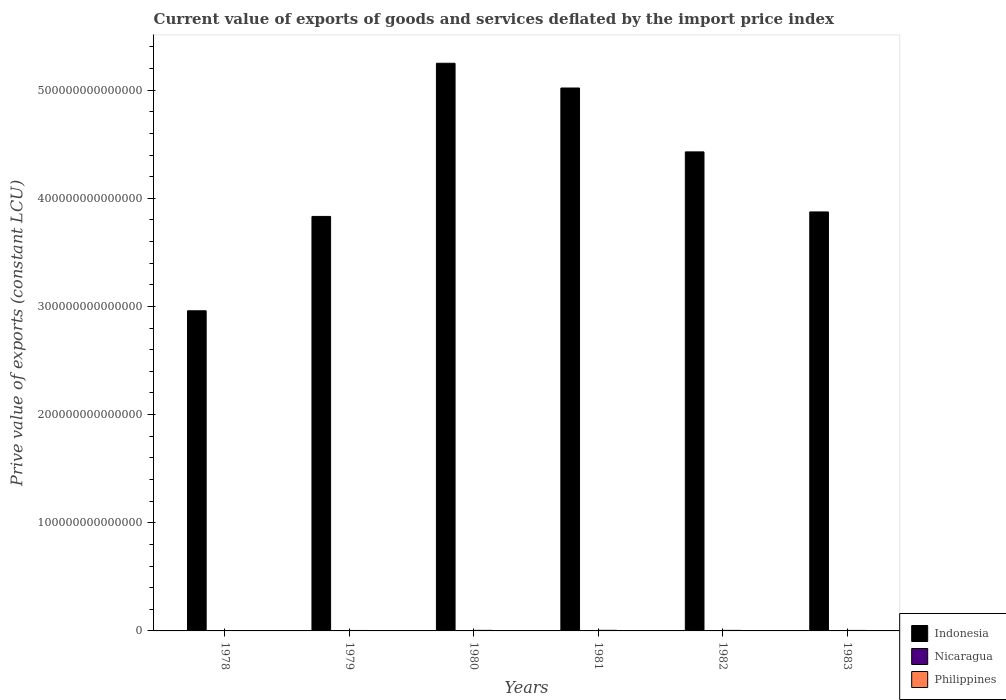How many different coloured bars are there?
Your answer should be compact. 3. How many bars are there on the 3rd tick from the left?
Provide a short and direct response. 3. How many bars are there on the 5th tick from the right?
Provide a succinct answer. 3. What is the label of the 2nd group of bars from the left?
Provide a succinct answer. 1979. In how many cases, is the number of bars for a given year not equal to the number of legend labels?
Make the answer very short. 0. What is the prive value of exports in Philippines in 1980?
Your answer should be compact. 5.16e+11. Across all years, what is the maximum prive value of exports in Philippines?
Your answer should be compact. 5.42e+11. Across all years, what is the minimum prive value of exports in Nicaragua?
Provide a succinct answer. 1.10e+1. In which year was the prive value of exports in Philippines minimum?
Offer a terse response. 1978. What is the total prive value of exports in Indonesia in the graph?
Your answer should be compact. 2.54e+15. What is the difference between the prive value of exports in Philippines in 1978 and that in 1983?
Your response must be concise. -9.46e+1. What is the difference between the prive value of exports in Nicaragua in 1981 and the prive value of exports in Philippines in 1982?
Give a very brief answer. -4.79e+11. What is the average prive value of exports in Indonesia per year?
Ensure brevity in your answer.  4.23e+14. In the year 1981, what is the difference between the prive value of exports in Nicaragua and prive value of exports in Philippines?
Your answer should be very brief. -5.29e+11. In how many years, is the prive value of exports in Indonesia greater than 440000000000000 LCU?
Offer a very short reply. 3. What is the ratio of the prive value of exports in Indonesia in 1978 to that in 1981?
Keep it short and to the point. 0.59. What is the difference between the highest and the second highest prive value of exports in Philippines?
Ensure brevity in your answer.  2.63e+1. What is the difference between the highest and the lowest prive value of exports in Nicaragua?
Provide a succinct answer. 1.02e+1. In how many years, is the prive value of exports in Nicaragua greater than the average prive value of exports in Nicaragua taken over all years?
Make the answer very short. 2. Is the sum of the prive value of exports in Indonesia in 1978 and 1979 greater than the maximum prive value of exports in Nicaragua across all years?
Your answer should be very brief. Yes. What does the 1st bar from the left in 1979 represents?
Keep it short and to the point. Indonesia. What does the 1st bar from the right in 1979 represents?
Your answer should be very brief. Philippines. How many bars are there?
Ensure brevity in your answer.  18. Are all the bars in the graph horizontal?
Make the answer very short. No. What is the difference between two consecutive major ticks on the Y-axis?
Offer a terse response. 1.00e+14. Does the graph contain any zero values?
Give a very brief answer. No. Does the graph contain grids?
Offer a very short reply. No. Where does the legend appear in the graph?
Ensure brevity in your answer.  Bottom right. How many legend labels are there?
Provide a succinct answer. 3. How are the legend labels stacked?
Provide a short and direct response. Vertical. What is the title of the graph?
Your response must be concise. Current value of exports of goods and services deflated by the import price index. What is the label or title of the X-axis?
Offer a very short reply. Years. What is the label or title of the Y-axis?
Give a very brief answer. Prive value of exports (constant LCU). What is the Prive value of exports (constant LCU) in Indonesia in 1978?
Your answer should be compact. 2.96e+14. What is the Prive value of exports (constant LCU) of Nicaragua in 1978?
Offer a very short reply. 1.93e+1. What is the Prive value of exports (constant LCU) in Philippines in 1978?
Provide a short and direct response. 3.72e+11. What is the Prive value of exports (constant LCU) of Indonesia in 1979?
Your answer should be very brief. 3.83e+14. What is the Prive value of exports (constant LCU) in Nicaragua in 1979?
Give a very brief answer. 2.13e+1. What is the Prive value of exports (constant LCU) in Philippines in 1979?
Keep it short and to the point. 4.22e+11. What is the Prive value of exports (constant LCU) of Indonesia in 1980?
Your answer should be very brief. 5.25e+14. What is the Prive value of exports (constant LCU) in Nicaragua in 1980?
Your response must be concise. 1.45e+1. What is the Prive value of exports (constant LCU) in Philippines in 1980?
Offer a terse response. 5.16e+11. What is the Prive value of exports (constant LCU) in Indonesia in 1981?
Provide a short and direct response. 5.02e+14. What is the Prive value of exports (constant LCU) of Nicaragua in 1981?
Provide a succinct answer. 1.32e+1. What is the Prive value of exports (constant LCU) in Philippines in 1981?
Make the answer very short. 5.42e+11. What is the Prive value of exports (constant LCU) in Indonesia in 1982?
Your answer should be compact. 4.43e+14. What is the Prive value of exports (constant LCU) of Nicaragua in 1982?
Offer a terse response. 1.10e+1. What is the Prive value of exports (constant LCU) of Philippines in 1982?
Provide a short and direct response. 4.93e+11. What is the Prive value of exports (constant LCU) in Indonesia in 1983?
Give a very brief answer. 3.87e+14. What is the Prive value of exports (constant LCU) in Nicaragua in 1983?
Offer a very short reply. 1.36e+1. What is the Prive value of exports (constant LCU) of Philippines in 1983?
Make the answer very short. 4.66e+11. Across all years, what is the maximum Prive value of exports (constant LCU) in Indonesia?
Your response must be concise. 5.25e+14. Across all years, what is the maximum Prive value of exports (constant LCU) in Nicaragua?
Ensure brevity in your answer.  2.13e+1. Across all years, what is the maximum Prive value of exports (constant LCU) of Philippines?
Your answer should be very brief. 5.42e+11. Across all years, what is the minimum Prive value of exports (constant LCU) in Indonesia?
Provide a short and direct response. 2.96e+14. Across all years, what is the minimum Prive value of exports (constant LCU) in Nicaragua?
Provide a short and direct response. 1.10e+1. Across all years, what is the minimum Prive value of exports (constant LCU) of Philippines?
Ensure brevity in your answer.  3.72e+11. What is the total Prive value of exports (constant LCU) of Indonesia in the graph?
Provide a succinct answer. 2.54e+15. What is the total Prive value of exports (constant LCU) in Nicaragua in the graph?
Ensure brevity in your answer.  9.29e+1. What is the total Prive value of exports (constant LCU) in Philippines in the graph?
Make the answer very short. 2.81e+12. What is the difference between the Prive value of exports (constant LCU) in Indonesia in 1978 and that in 1979?
Make the answer very short. -8.72e+13. What is the difference between the Prive value of exports (constant LCU) in Nicaragua in 1978 and that in 1979?
Keep it short and to the point. -1.97e+09. What is the difference between the Prive value of exports (constant LCU) in Philippines in 1978 and that in 1979?
Provide a succinct answer. -4.98e+1. What is the difference between the Prive value of exports (constant LCU) of Indonesia in 1978 and that in 1980?
Ensure brevity in your answer.  -2.29e+14. What is the difference between the Prive value of exports (constant LCU) of Nicaragua in 1978 and that in 1980?
Provide a short and direct response. 4.82e+09. What is the difference between the Prive value of exports (constant LCU) of Philippines in 1978 and that in 1980?
Your answer should be compact. -1.44e+11. What is the difference between the Prive value of exports (constant LCU) of Indonesia in 1978 and that in 1981?
Keep it short and to the point. -2.06e+14. What is the difference between the Prive value of exports (constant LCU) in Nicaragua in 1978 and that in 1981?
Offer a terse response. 6.08e+09. What is the difference between the Prive value of exports (constant LCU) of Philippines in 1978 and that in 1981?
Your response must be concise. -1.70e+11. What is the difference between the Prive value of exports (constant LCU) in Indonesia in 1978 and that in 1982?
Offer a terse response. -1.47e+14. What is the difference between the Prive value of exports (constant LCU) in Nicaragua in 1978 and that in 1982?
Ensure brevity in your answer.  8.25e+09. What is the difference between the Prive value of exports (constant LCU) in Philippines in 1978 and that in 1982?
Offer a very short reply. -1.21e+11. What is the difference between the Prive value of exports (constant LCU) in Indonesia in 1978 and that in 1983?
Keep it short and to the point. -9.14e+13. What is the difference between the Prive value of exports (constant LCU) of Nicaragua in 1978 and that in 1983?
Give a very brief answer. 5.69e+09. What is the difference between the Prive value of exports (constant LCU) in Philippines in 1978 and that in 1983?
Offer a very short reply. -9.46e+1. What is the difference between the Prive value of exports (constant LCU) of Indonesia in 1979 and that in 1980?
Provide a succinct answer. -1.42e+14. What is the difference between the Prive value of exports (constant LCU) of Nicaragua in 1979 and that in 1980?
Your answer should be compact. 6.79e+09. What is the difference between the Prive value of exports (constant LCU) in Philippines in 1979 and that in 1980?
Your answer should be compact. -9.42e+1. What is the difference between the Prive value of exports (constant LCU) of Indonesia in 1979 and that in 1981?
Your answer should be compact. -1.19e+14. What is the difference between the Prive value of exports (constant LCU) of Nicaragua in 1979 and that in 1981?
Give a very brief answer. 8.05e+09. What is the difference between the Prive value of exports (constant LCU) of Philippines in 1979 and that in 1981?
Give a very brief answer. -1.20e+11. What is the difference between the Prive value of exports (constant LCU) of Indonesia in 1979 and that in 1982?
Provide a succinct answer. -5.97e+13. What is the difference between the Prive value of exports (constant LCU) in Nicaragua in 1979 and that in 1982?
Your answer should be compact. 1.02e+1. What is the difference between the Prive value of exports (constant LCU) of Philippines in 1979 and that in 1982?
Keep it short and to the point. -7.10e+1. What is the difference between the Prive value of exports (constant LCU) in Indonesia in 1979 and that in 1983?
Ensure brevity in your answer.  -4.15e+12. What is the difference between the Prive value of exports (constant LCU) in Nicaragua in 1979 and that in 1983?
Make the answer very short. 7.66e+09. What is the difference between the Prive value of exports (constant LCU) of Philippines in 1979 and that in 1983?
Your answer should be compact. -4.48e+1. What is the difference between the Prive value of exports (constant LCU) in Indonesia in 1980 and that in 1981?
Your answer should be very brief. 2.29e+13. What is the difference between the Prive value of exports (constant LCU) of Nicaragua in 1980 and that in 1981?
Give a very brief answer. 1.26e+09. What is the difference between the Prive value of exports (constant LCU) of Philippines in 1980 and that in 1981?
Your answer should be very brief. -2.63e+1. What is the difference between the Prive value of exports (constant LCU) of Indonesia in 1980 and that in 1982?
Your answer should be compact. 8.20e+13. What is the difference between the Prive value of exports (constant LCU) in Nicaragua in 1980 and that in 1982?
Make the answer very short. 3.43e+09. What is the difference between the Prive value of exports (constant LCU) in Philippines in 1980 and that in 1982?
Your answer should be very brief. 2.32e+1. What is the difference between the Prive value of exports (constant LCU) in Indonesia in 1980 and that in 1983?
Give a very brief answer. 1.37e+14. What is the difference between the Prive value of exports (constant LCU) in Nicaragua in 1980 and that in 1983?
Keep it short and to the point. 8.69e+08. What is the difference between the Prive value of exports (constant LCU) in Philippines in 1980 and that in 1983?
Offer a very short reply. 4.93e+1. What is the difference between the Prive value of exports (constant LCU) of Indonesia in 1981 and that in 1982?
Your answer should be very brief. 5.91e+13. What is the difference between the Prive value of exports (constant LCU) of Nicaragua in 1981 and that in 1982?
Give a very brief answer. 2.17e+09. What is the difference between the Prive value of exports (constant LCU) in Philippines in 1981 and that in 1982?
Offer a terse response. 4.95e+1. What is the difference between the Prive value of exports (constant LCU) of Indonesia in 1981 and that in 1983?
Provide a succinct answer. 1.15e+14. What is the difference between the Prive value of exports (constant LCU) of Nicaragua in 1981 and that in 1983?
Provide a succinct answer. -3.90e+08. What is the difference between the Prive value of exports (constant LCU) of Philippines in 1981 and that in 1983?
Your response must be concise. 7.56e+1. What is the difference between the Prive value of exports (constant LCU) in Indonesia in 1982 and that in 1983?
Your answer should be compact. 5.55e+13. What is the difference between the Prive value of exports (constant LCU) in Nicaragua in 1982 and that in 1983?
Give a very brief answer. -2.56e+09. What is the difference between the Prive value of exports (constant LCU) in Philippines in 1982 and that in 1983?
Give a very brief answer. 2.62e+1. What is the difference between the Prive value of exports (constant LCU) in Indonesia in 1978 and the Prive value of exports (constant LCU) in Nicaragua in 1979?
Ensure brevity in your answer.  2.96e+14. What is the difference between the Prive value of exports (constant LCU) of Indonesia in 1978 and the Prive value of exports (constant LCU) of Philippines in 1979?
Your response must be concise. 2.96e+14. What is the difference between the Prive value of exports (constant LCU) in Nicaragua in 1978 and the Prive value of exports (constant LCU) in Philippines in 1979?
Provide a succinct answer. -4.02e+11. What is the difference between the Prive value of exports (constant LCU) of Indonesia in 1978 and the Prive value of exports (constant LCU) of Nicaragua in 1980?
Your answer should be compact. 2.96e+14. What is the difference between the Prive value of exports (constant LCU) of Indonesia in 1978 and the Prive value of exports (constant LCU) of Philippines in 1980?
Provide a short and direct response. 2.95e+14. What is the difference between the Prive value of exports (constant LCU) in Nicaragua in 1978 and the Prive value of exports (constant LCU) in Philippines in 1980?
Provide a succinct answer. -4.96e+11. What is the difference between the Prive value of exports (constant LCU) in Indonesia in 1978 and the Prive value of exports (constant LCU) in Nicaragua in 1981?
Your response must be concise. 2.96e+14. What is the difference between the Prive value of exports (constant LCU) of Indonesia in 1978 and the Prive value of exports (constant LCU) of Philippines in 1981?
Ensure brevity in your answer.  2.95e+14. What is the difference between the Prive value of exports (constant LCU) in Nicaragua in 1978 and the Prive value of exports (constant LCU) in Philippines in 1981?
Offer a terse response. -5.23e+11. What is the difference between the Prive value of exports (constant LCU) of Indonesia in 1978 and the Prive value of exports (constant LCU) of Nicaragua in 1982?
Your response must be concise. 2.96e+14. What is the difference between the Prive value of exports (constant LCU) in Indonesia in 1978 and the Prive value of exports (constant LCU) in Philippines in 1982?
Keep it short and to the point. 2.96e+14. What is the difference between the Prive value of exports (constant LCU) in Nicaragua in 1978 and the Prive value of exports (constant LCU) in Philippines in 1982?
Your answer should be compact. -4.73e+11. What is the difference between the Prive value of exports (constant LCU) in Indonesia in 1978 and the Prive value of exports (constant LCU) in Nicaragua in 1983?
Keep it short and to the point. 2.96e+14. What is the difference between the Prive value of exports (constant LCU) of Indonesia in 1978 and the Prive value of exports (constant LCU) of Philippines in 1983?
Make the answer very short. 2.96e+14. What is the difference between the Prive value of exports (constant LCU) of Nicaragua in 1978 and the Prive value of exports (constant LCU) of Philippines in 1983?
Ensure brevity in your answer.  -4.47e+11. What is the difference between the Prive value of exports (constant LCU) of Indonesia in 1979 and the Prive value of exports (constant LCU) of Nicaragua in 1980?
Your response must be concise. 3.83e+14. What is the difference between the Prive value of exports (constant LCU) in Indonesia in 1979 and the Prive value of exports (constant LCU) in Philippines in 1980?
Your answer should be very brief. 3.83e+14. What is the difference between the Prive value of exports (constant LCU) of Nicaragua in 1979 and the Prive value of exports (constant LCU) of Philippines in 1980?
Offer a terse response. -4.94e+11. What is the difference between the Prive value of exports (constant LCU) of Indonesia in 1979 and the Prive value of exports (constant LCU) of Nicaragua in 1981?
Give a very brief answer. 3.83e+14. What is the difference between the Prive value of exports (constant LCU) in Indonesia in 1979 and the Prive value of exports (constant LCU) in Philippines in 1981?
Ensure brevity in your answer.  3.83e+14. What is the difference between the Prive value of exports (constant LCU) in Nicaragua in 1979 and the Prive value of exports (constant LCU) in Philippines in 1981?
Your response must be concise. -5.21e+11. What is the difference between the Prive value of exports (constant LCU) of Indonesia in 1979 and the Prive value of exports (constant LCU) of Nicaragua in 1982?
Make the answer very short. 3.83e+14. What is the difference between the Prive value of exports (constant LCU) of Indonesia in 1979 and the Prive value of exports (constant LCU) of Philippines in 1982?
Your answer should be compact. 3.83e+14. What is the difference between the Prive value of exports (constant LCU) in Nicaragua in 1979 and the Prive value of exports (constant LCU) in Philippines in 1982?
Offer a very short reply. -4.71e+11. What is the difference between the Prive value of exports (constant LCU) of Indonesia in 1979 and the Prive value of exports (constant LCU) of Nicaragua in 1983?
Offer a very short reply. 3.83e+14. What is the difference between the Prive value of exports (constant LCU) of Indonesia in 1979 and the Prive value of exports (constant LCU) of Philippines in 1983?
Your answer should be compact. 3.83e+14. What is the difference between the Prive value of exports (constant LCU) of Nicaragua in 1979 and the Prive value of exports (constant LCU) of Philippines in 1983?
Keep it short and to the point. -4.45e+11. What is the difference between the Prive value of exports (constant LCU) of Indonesia in 1980 and the Prive value of exports (constant LCU) of Nicaragua in 1981?
Your answer should be compact. 5.25e+14. What is the difference between the Prive value of exports (constant LCU) in Indonesia in 1980 and the Prive value of exports (constant LCU) in Philippines in 1981?
Ensure brevity in your answer.  5.24e+14. What is the difference between the Prive value of exports (constant LCU) in Nicaragua in 1980 and the Prive value of exports (constant LCU) in Philippines in 1981?
Provide a succinct answer. -5.28e+11. What is the difference between the Prive value of exports (constant LCU) in Indonesia in 1980 and the Prive value of exports (constant LCU) in Nicaragua in 1982?
Offer a terse response. 5.25e+14. What is the difference between the Prive value of exports (constant LCU) of Indonesia in 1980 and the Prive value of exports (constant LCU) of Philippines in 1982?
Ensure brevity in your answer.  5.24e+14. What is the difference between the Prive value of exports (constant LCU) of Nicaragua in 1980 and the Prive value of exports (constant LCU) of Philippines in 1982?
Offer a very short reply. -4.78e+11. What is the difference between the Prive value of exports (constant LCU) in Indonesia in 1980 and the Prive value of exports (constant LCU) in Nicaragua in 1983?
Make the answer very short. 5.25e+14. What is the difference between the Prive value of exports (constant LCU) in Indonesia in 1980 and the Prive value of exports (constant LCU) in Philippines in 1983?
Offer a terse response. 5.24e+14. What is the difference between the Prive value of exports (constant LCU) of Nicaragua in 1980 and the Prive value of exports (constant LCU) of Philippines in 1983?
Make the answer very short. -4.52e+11. What is the difference between the Prive value of exports (constant LCU) in Indonesia in 1981 and the Prive value of exports (constant LCU) in Nicaragua in 1982?
Offer a terse response. 5.02e+14. What is the difference between the Prive value of exports (constant LCU) in Indonesia in 1981 and the Prive value of exports (constant LCU) in Philippines in 1982?
Make the answer very short. 5.01e+14. What is the difference between the Prive value of exports (constant LCU) of Nicaragua in 1981 and the Prive value of exports (constant LCU) of Philippines in 1982?
Give a very brief answer. -4.79e+11. What is the difference between the Prive value of exports (constant LCU) of Indonesia in 1981 and the Prive value of exports (constant LCU) of Nicaragua in 1983?
Keep it short and to the point. 5.02e+14. What is the difference between the Prive value of exports (constant LCU) in Indonesia in 1981 and the Prive value of exports (constant LCU) in Philippines in 1983?
Make the answer very short. 5.02e+14. What is the difference between the Prive value of exports (constant LCU) in Nicaragua in 1981 and the Prive value of exports (constant LCU) in Philippines in 1983?
Offer a very short reply. -4.53e+11. What is the difference between the Prive value of exports (constant LCU) of Indonesia in 1982 and the Prive value of exports (constant LCU) of Nicaragua in 1983?
Keep it short and to the point. 4.43e+14. What is the difference between the Prive value of exports (constant LCU) of Indonesia in 1982 and the Prive value of exports (constant LCU) of Philippines in 1983?
Ensure brevity in your answer.  4.42e+14. What is the difference between the Prive value of exports (constant LCU) of Nicaragua in 1982 and the Prive value of exports (constant LCU) of Philippines in 1983?
Your response must be concise. -4.55e+11. What is the average Prive value of exports (constant LCU) in Indonesia per year?
Your answer should be very brief. 4.23e+14. What is the average Prive value of exports (constant LCU) in Nicaragua per year?
Offer a very short reply. 1.55e+1. What is the average Prive value of exports (constant LCU) of Philippines per year?
Your answer should be compact. 4.68e+11. In the year 1978, what is the difference between the Prive value of exports (constant LCU) of Indonesia and Prive value of exports (constant LCU) of Nicaragua?
Provide a short and direct response. 2.96e+14. In the year 1978, what is the difference between the Prive value of exports (constant LCU) in Indonesia and Prive value of exports (constant LCU) in Philippines?
Make the answer very short. 2.96e+14. In the year 1978, what is the difference between the Prive value of exports (constant LCU) of Nicaragua and Prive value of exports (constant LCU) of Philippines?
Give a very brief answer. -3.52e+11. In the year 1979, what is the difference between the Prive value of exports (constant LCU) in Indonesia and Prive value of exports (constant LCU) in Nicaragua?
Your response must be concise. 3.83e+14. In the year 1979, what is the difference between the Prive value of exports (constant LCU) in Indonesia and Prive value of exports (constant LCU) in Philippines?
Provide a succinct answer. 3.83e+14. In the year 1979, what is the difference between the Prive value of exports (constant LCU) of Nicaragua and Prive value of exports (constant LCU) of Philippines?
Your response must be concise. -4.00e+11. In the year 1980, what is the difference between the Prive value of exports (constant LCU) of Indonesia and Prive value of exports (constant LCU) of Nicaragua?
Give a very brief answer. 5.25e+14. In the year 1980, what is the difference between the Prive value of exports (constant LCU) in Indonesia and Prive value of exports (constant LCU) in Philippines?
Provide a short and direct response. 5.24e+14. In the year 1980, what is the difference between the Prive value of exports (constant LCU) of Nicaragua and Prive value of exports (constant LCU) of Philippines?
Your response must be concise. -5.01e+11. In the year 1981, what is the difference between the Prive value of exports (constant LCU) of Indonesia and Prive value of exports (constant LCU) of Nicaragua?
Your answer should be very brief. 5.02e+14. In the year 1981, what is the difference between the Prive value of exports (constant LCU) in Indonesia and Prive value of exports (constant LCU) in Philippines?
Your answer should be compact. 5.01e+14. In the year 1981, what is the difference between the Prive value of exports (constant LCU) in Nicaragua and Prive value of exports (constant LCU) in Philippines?
Provide a short and direct response. -5.29e+11. In the year 1982, what is the difference between the Prive value of exports (constant LCU) in Indonesia and Prive value of exports (constant LCU) in Nicaragua?
Keep it short and to the point. 4.43e+14. In the year 1982, what is the difference between the Prive value of exports (constant LCU) of Indonesia and Prive value of exports (constant LCU) of Philippines?
Your answer should be very brief. 4.42e+14. In the year 1982, what is the difference between the Prive value of exports (constant LCU) in Nicaragua and Prive value of exports (constant LCU) in Philippines?
Offer a very short reply. -4.82e+11. In the year 1983, what is the difference between the Prive value of exports (constant LCU) in Indonesia and Prive value of exports (constant LCU) in Nicaragua?
Keep it short and to the point. 3.87e+14. In the year 1983, what is the difference between the Prive value of exports (constant LCU) of Indonesia and Prive value of exports (constant LCU) of Philippines?
Your response must be concise. 3.87e+14. In the year 1983, what is the difference between the Prive value of exports (constant LCU) of Nicaragua and Prive value of exports (constant LCU) of Philippines?
Your answer should be compact. -4.53e+11. What is the ratio of the Prive value of exports (constant LCU) of Indonesia in 1978 to that in 1979?
Provide a short and direct response. 0.77. What is the ratio of the Prive value of exports (constant LCU) of Nicaragua in 1978 to that in 1979?
Offer a terse response. 0.91. What is the ratio of the Prive value of exports (constant LCU) in Philippines in 1978 to that in 1979?
Make the answer very short. 0.88. What is the ratio of the Prive value of exports (constant LCU) in Indonesia in 1978 to that in 1980?
Provide a short and direct response. 0.56. What is the ratio of the Prive value of exports (constant LCU) in Nicaragua in 1978 to that in 1980?
Ensure brevity in your answer.  1.33. What is the ratio of the Prive value of exports (constant LCU) in Philippines in 1978 to that in 1980?
Your answer should be very brief. 0.72. What is the ratio of the Prive value of exports (constant LCU) of Indonesia in 1978 to that in 1981?
Your answer should be compact. 0.59. What is the ratio of the Prive value of exports (constant LCU) in Nicaragua in 1978 to that in 1981?
Make the answer very short. 1.46. What is the ratio of the Prive value of exports (constant LCU) of Philippines in 1978 to that in 1981?
Make the answer very short. 0.69. What is the ratio of the Prive value of exports (constant LCU) of Indonesia in 1978 to that in 1982?
Keep it short and to the point. 0.67. What is the ratio of the Prive value of exports (constant LCU) of Nicaragua in 1978 to that in 1982?
Give a very brief answer. 1.75. What is the ratio of the Prive value of exports (constant LCU) of Philippines in 1978 to that in 1982?
Your answer should be very brief. 0.75. What is the ratio of the Prive value of exports (constant LCU) in Indonesia in 1978 to that in 1983?
Offer a very short reply. 0.76. What is the ratio of the Prive value of exports (constant LCU) of Nicaragua in 1978 to that in 1983?
Ensure brevity in your answer.  1.42. What is the ratio of the Prive value of exports (constant LCU) of Philippines in 1978 to that in 1983?
Offer a terse response. 0.8. What is the ratio of the Prive value of exports (constant LCU) in Indonesia in 1979 to that in 1980?
Offer a terse response. 0.73. What is the ratio of the Prive value of exports (constant LCU) in Nicaragua in 1979 to that in 1980?
Give a very brief answer. 1.47. What is the ratio of the Prive value of exports (constant LCU) in Philippines in 1979 to that in 1980?
Offer a terse response. 0.82. What is the ratio of the Prive value of exports (constant LCU) of Indonesia in 1979 to that in 1981?
Give a very brief answer. 0.76. What is the ratio of the Prive value of exports (constant LCU) in Nicaragua in 1979 to that in 1981?
Offer a terse response. 1.61. What is the ratio of the Prive value of exports (constant LCU) in Philippines in 1979 to that in 1981?
Give a very brief answer. 0.78. What is the ratio of the Prive value of exports (constant LCU) in Indonesia in 1979 to that in 1982?
Your response must be concise. 0.87. What is the ratio of the Prive value of exports (constant LCU) of Nicaragua in 1979 to that in 1982?
Keep it short and to the point. 1.93. What is the ratio of the Prive value of exports (constant LCU) of Philippines in 1979 to that in 1982?
Your answer should be very brief. 0.86. What is the ratio of the Prive value of exports (constant LCU) in Indonesia in 1979 to that in 1983?
Give a very brief answer. 0.99. What is the ratio of the Prive value of exports (constant LCU) of Nicaragua in 1979 to that in 1983?
Give a very brief answer. 1.56. What is the ratio of the Prive value of exports (constant LCU) of Philippines in 1979 to that in 1983?
Your response must be concise. 0.9. What is the ratio of the Prive value of exports (constant LCU) in Indonesia in 1980 to that in 1981?
Your answer should be compact. 1.05. What is the ratio of the Prive value of exports (constant LCU) of Nicaragua in 1980 to that in 1981?
Provide a short and direct response. 1.1. What is the ratio of the Prive value of exports (constant LCU) in Philippines in 1980 to that in 1981?
Ensure brevity in your answer.  0.95. What is the ratio of the Prive value of exports (constant LCU) of Indonesia in 1980 to that in 1982?
Make the answer very short. 1.19. What is the ratio of the Prive value of exports (constant LCU) of Nicaragua in 1980 to that in 1982?
Your answer should be very brief. 1.31. What is the ratio of the Prive value of exports (constant LCU) in Philippines in 1980 to that in 1982?
Your response must be concise. 1.05. What is the ratio of the Prive value of exports (constant LCU) in Indonesia in 1980 to that in 1983?
Your response must be concise. 1.35. What is the ratio of the Prive value of exports (constant LCU) in Nicaragua in 1980 to that in 1983?
Offer a very short reply. 1.06. What is the ratio of the Prive value of exports (constant LCU) in Philippines in 1980 to that in 1983?
Your response must be concise. 1.11. What is the ratio of the Prive value of exports (constant LCU) in Indonesia in 1981 to that in 1982?
Your answer should be very brief. 1.13. What is the ratio of the Prive value of exports (constant LCU) in Nicaragua in 1981 to that in 1982?
Keep it short and to the point. 1.2. What is the ratio of the Prive value of exports (constant LCU) in Philippines in 1981 to that in 1982?
Offer a very short reply. 1.1. What is the ratio of the Prive value of exports (constant LCU) in Indonesia in 1981 to that in 1983?
Your answer should be compact. 1.3. What is the ratio of the Prive value of exports (constant LCU) in Nicaragua in 1981 to that in 1983?
Provide a succinct answer. 0.97. What is the ratio of the Prive value of exports (constant LCU) in Philippines in 1981 to that in 1983?
Offer a terse response. 1.16. What is the ratio of the Prive value of exports (constant LCU) of Indonesia in 1982 to that in 1983?
Your answer should be compact. 1.14. What is the ratio of the Prive value of exports (constant LCU) in Nicaragua in 1982 to that in 1983?
Offer a terse response. 0.81. What is the ratio of the Prive value of exports (constant LCU) of Philippines in 1982 to that in 1983?
Provide a succinct answer. 1.06. What is the difference between the highest and the second highest Prive value of exports (constant LCU) of Indonesia?
Offer a very short reply. 2.29e+13. What is the difference between the highest and the second highest Prive value of exports (constant LCU) in Nicaragua?
Provide a succinct answer. 1.97e+09. What is the difference between the highest and the second highest Prive value of exports (constant LCU) in Philippines?
Offer a very short reply. 2.63e+1. What is the difference between the highest and the lowest Prive value of exports (constant LCU) of Indonesia?
Your response must be concise. 2.29e+14. What is the difference between the highest and the lowest Prive value of exports (constant LCU) of Nicaragua?
Your answer should be very brief. 1.02e+1. What is the difference between the highest and the lowest Prive value of exports (constant LCU) of Philippines?
Provide a short and direct response. 1.70e+11. 